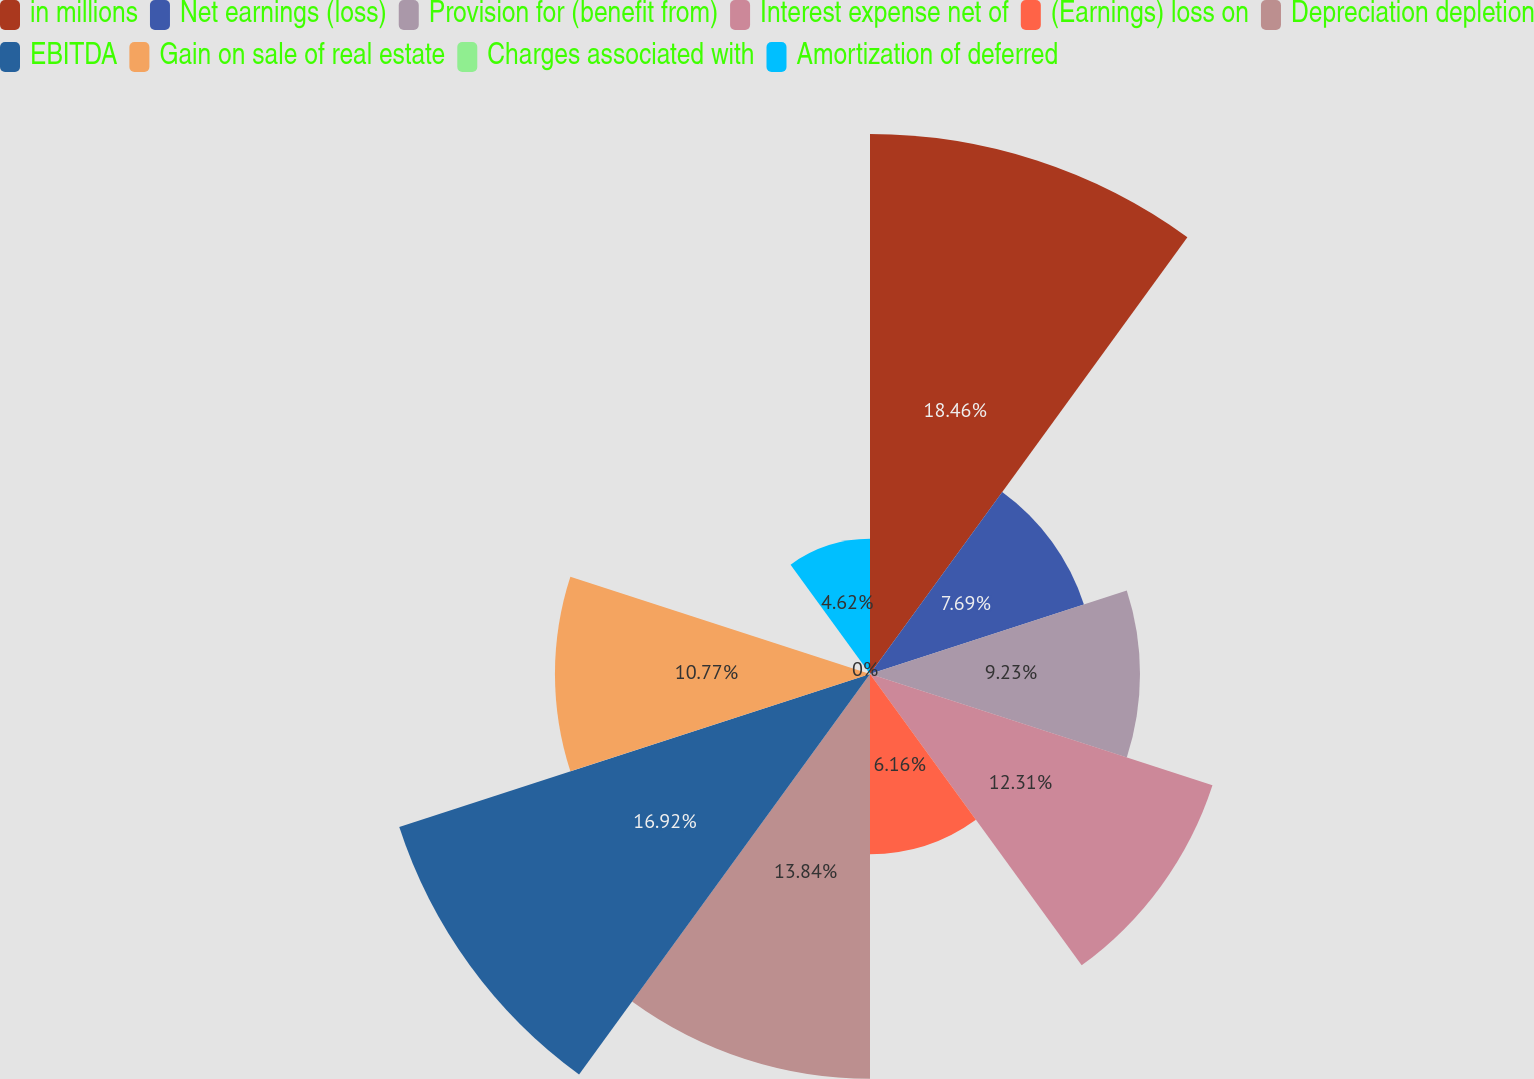Convert chart. <chart><loc_0><loc_0><loc_500><loc_500><pie_chart><fcel>in millions<fcel>Net earnings (loss)<fcel>Provision for (benefit from)<fcel>Interest expense net of<fcel>(Earnings) loss on<fcel>Depreciation depletion<fcel>EBITDA<fcel>Gain on sale of real estate<fcel>Charges associated with<fcel>Amortization of deferred<nl><fcel>18.46%<fcel>7.69%<fcel>9.23%<fcel>12.31%<fcel>6.16%<fcel>13.84%<fcel>16.92%<fcel>10.77%<fcel>0.0%<fcel>4.62%<nl></chart> 